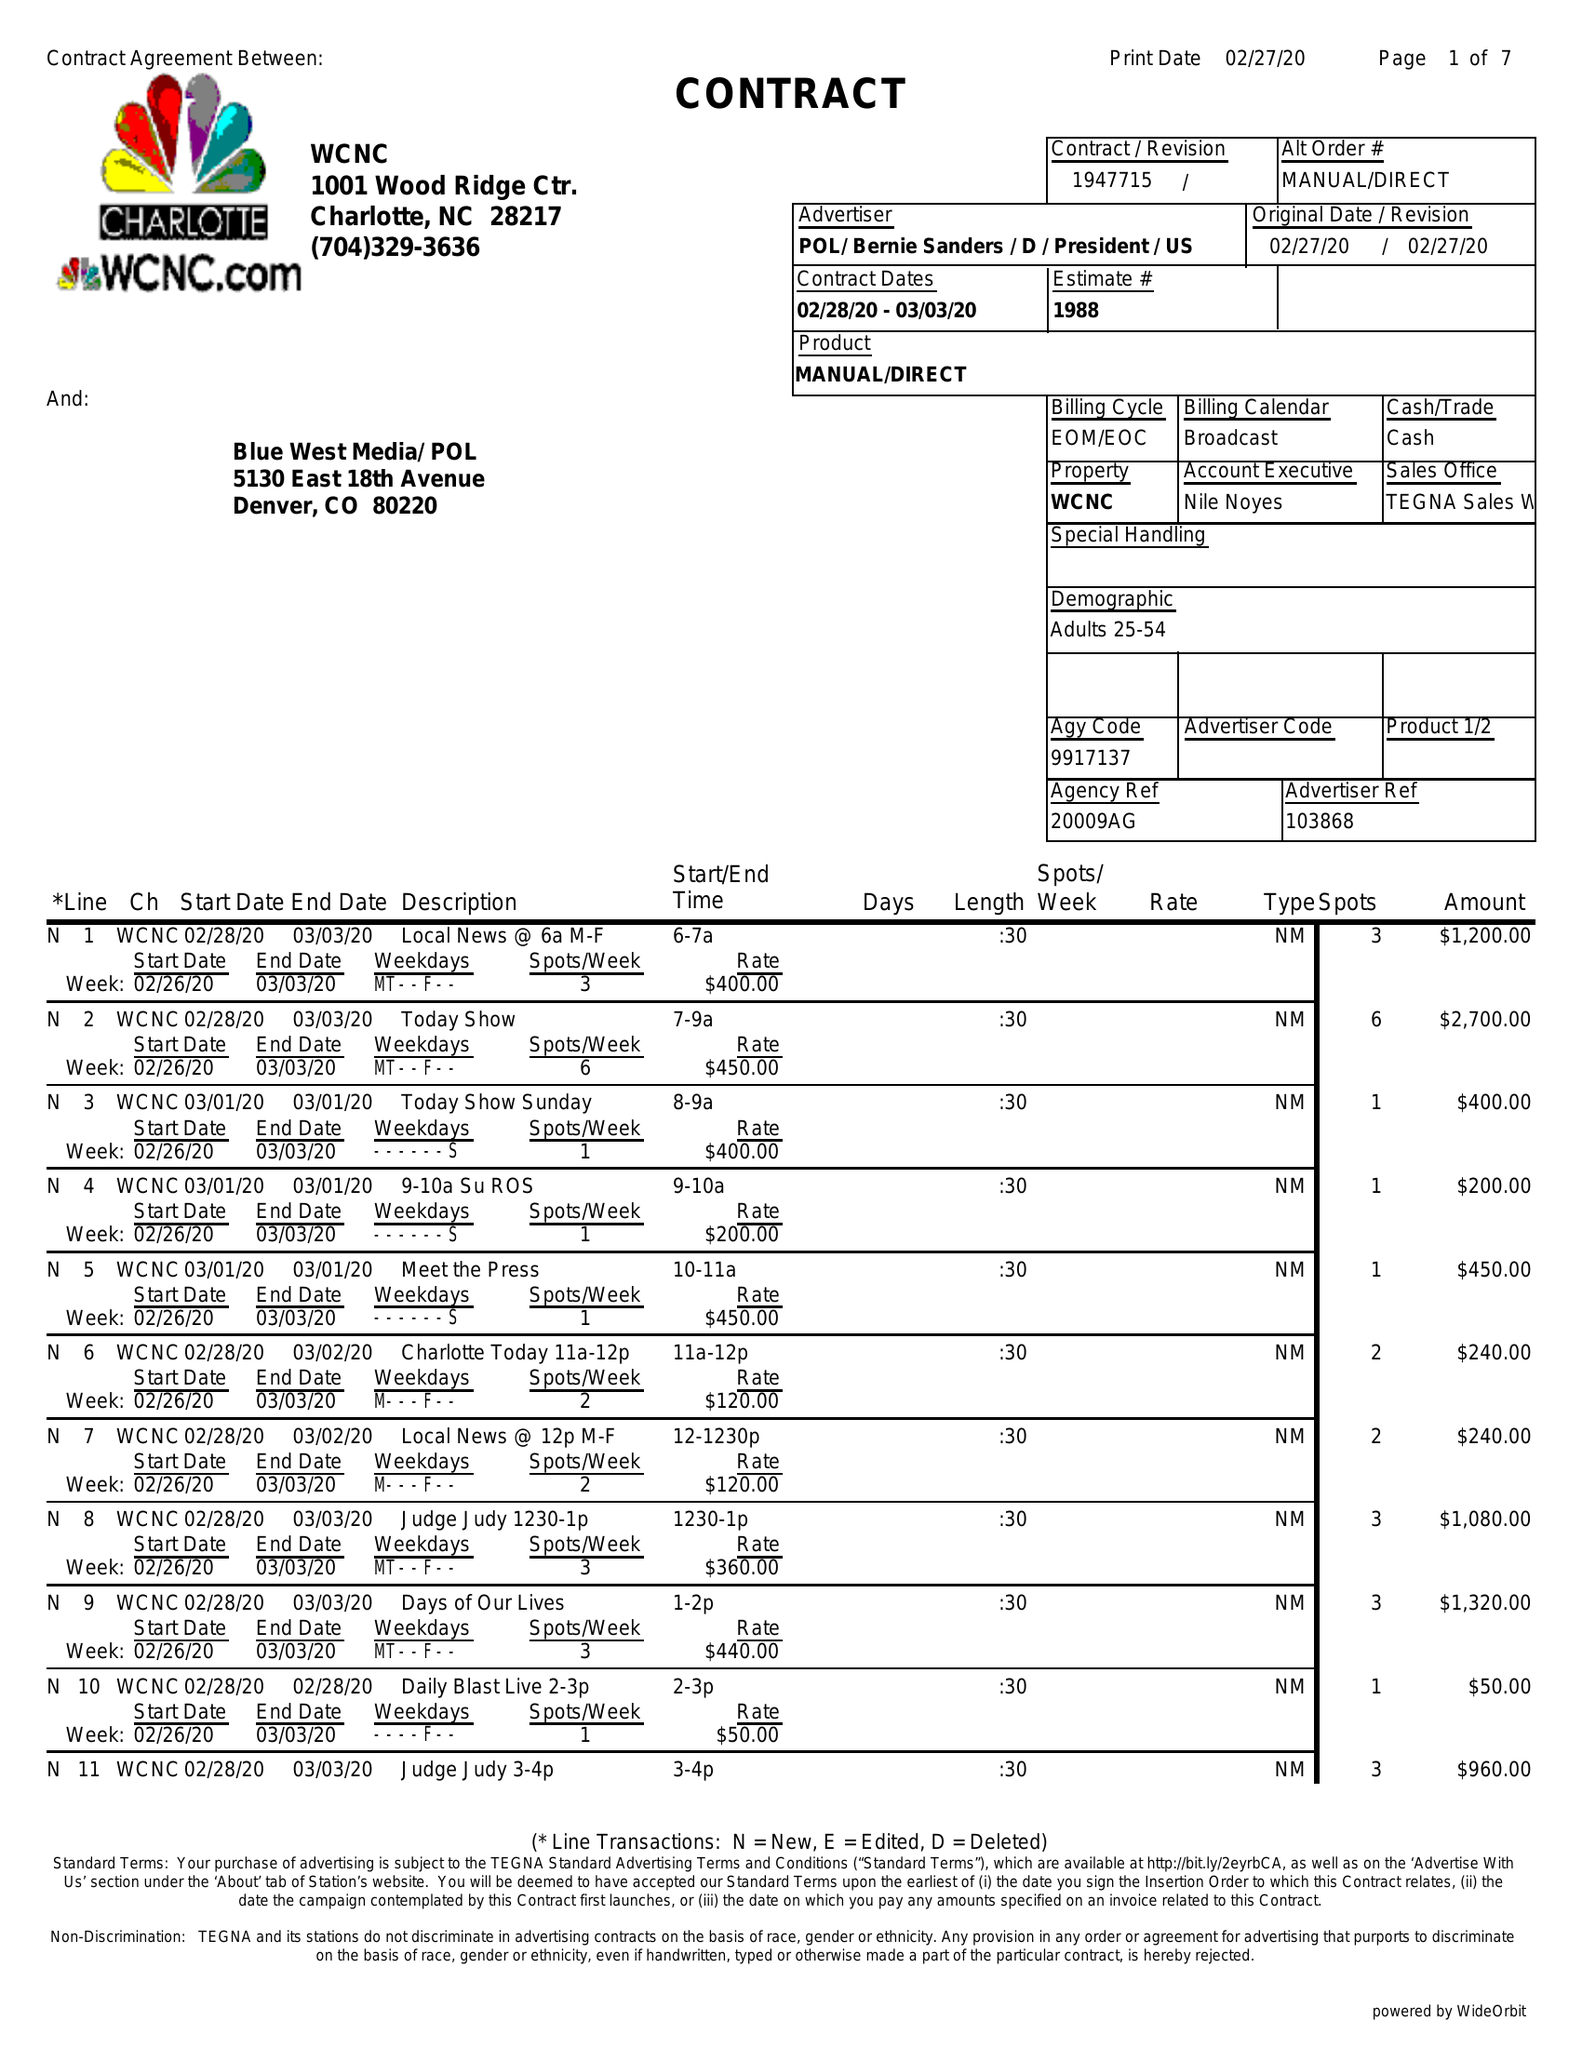What is the value for the flight_from?
Answer the question using a single word or phrase. 02/28/20 